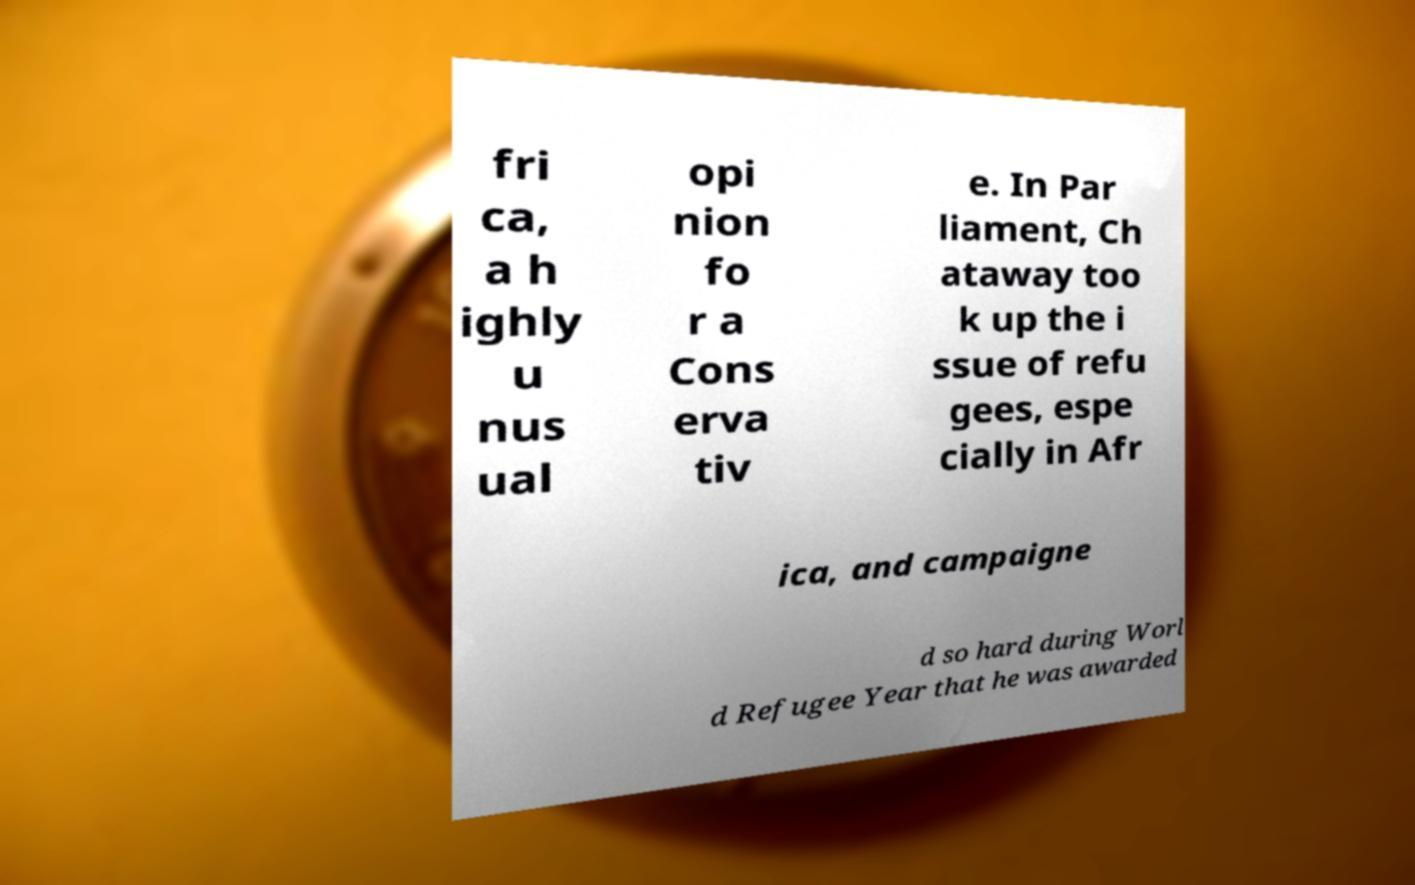Please identify and transcribe the text found in this image. fri ca, a h ighly u nus ual opi nion fo r a Cons erva tiv e. In Par liament, Ch ataway too k up the i ssue of refu gees, espe cially in Afr ica, and campaigne d so hard during Worl d Refugee Year that he was awarded 